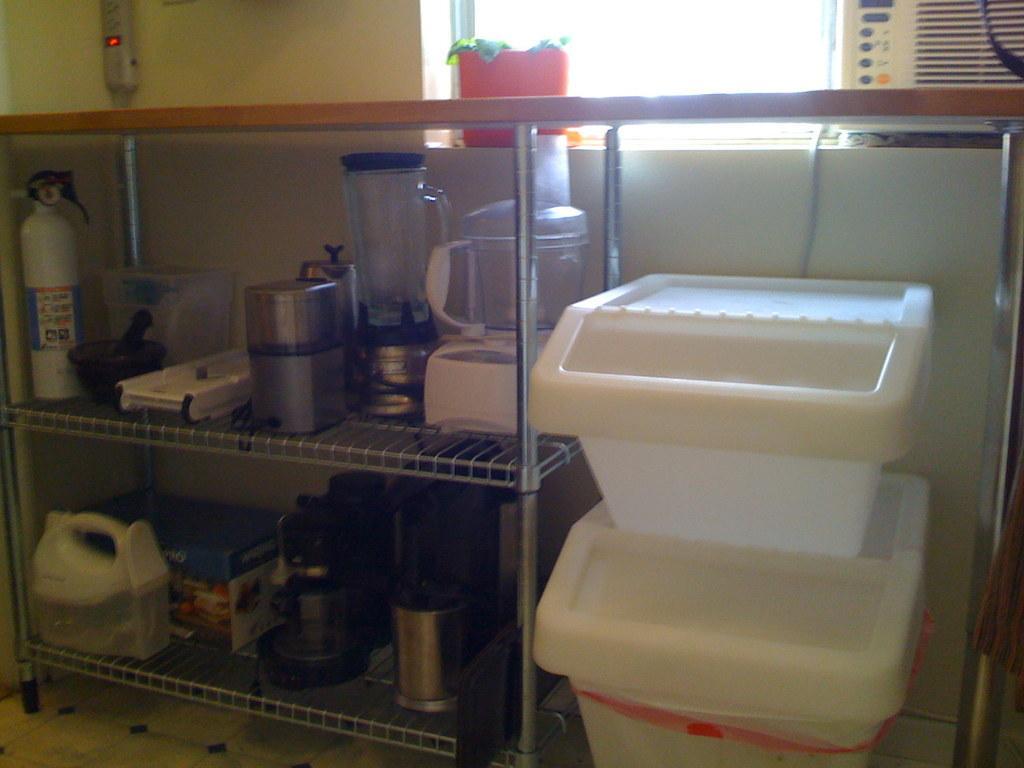Can you describe this image briefly? In this image on the right side there are some containers, and on the left side there is one table and in that table we could see some vessels, mixer jar, bowls, boxes and some bottles. In the background there is a window and one pot. 